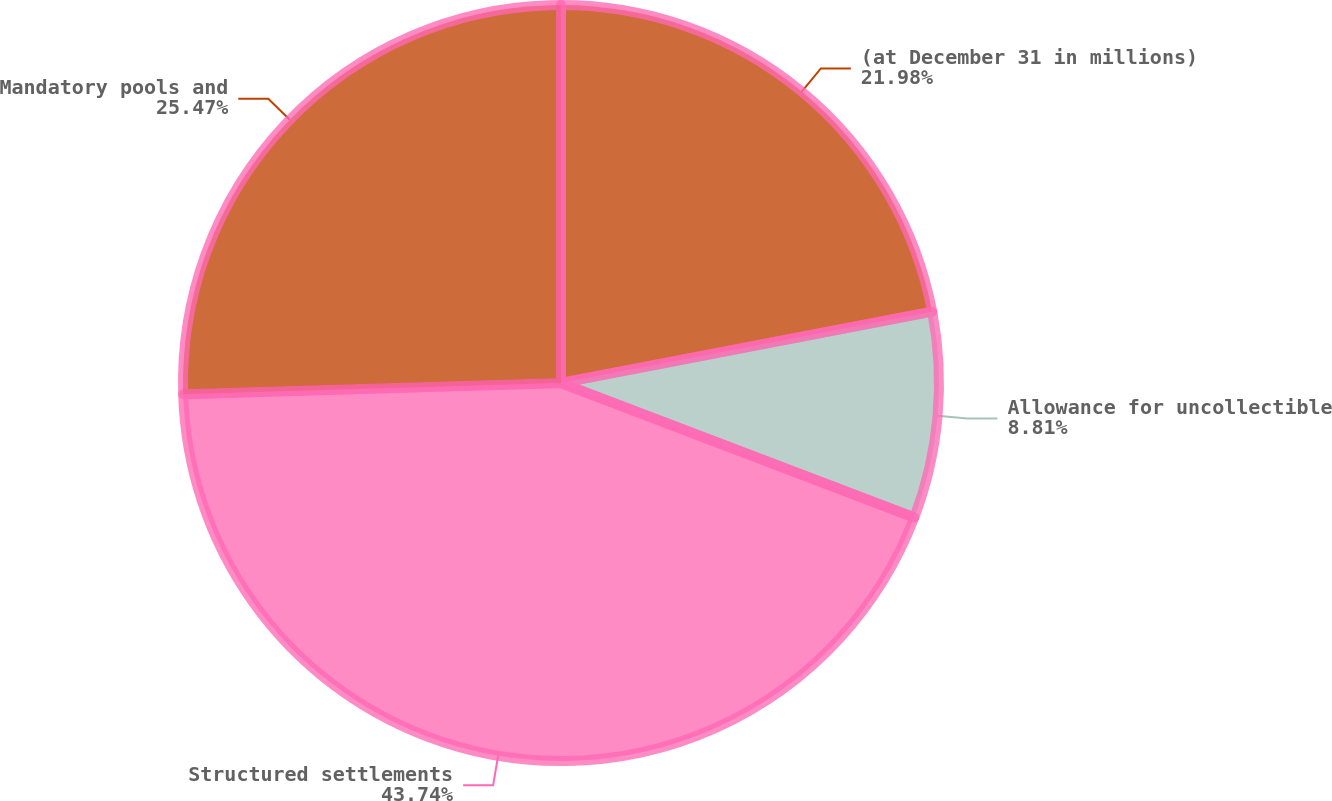Convert chart to OTSL. <chart><loc_0><loc_0><loc_500><loc_500><pie_chart><fcel>(at December 31 in millions)<fcel>Allowance for uncollectible<fcel>Structured settlements<fcel>Mandatory pools and<nl><fcel>21.98%<fcel>8.81%<fcel>43.74%<fcel>25.47%<nl></chart> 